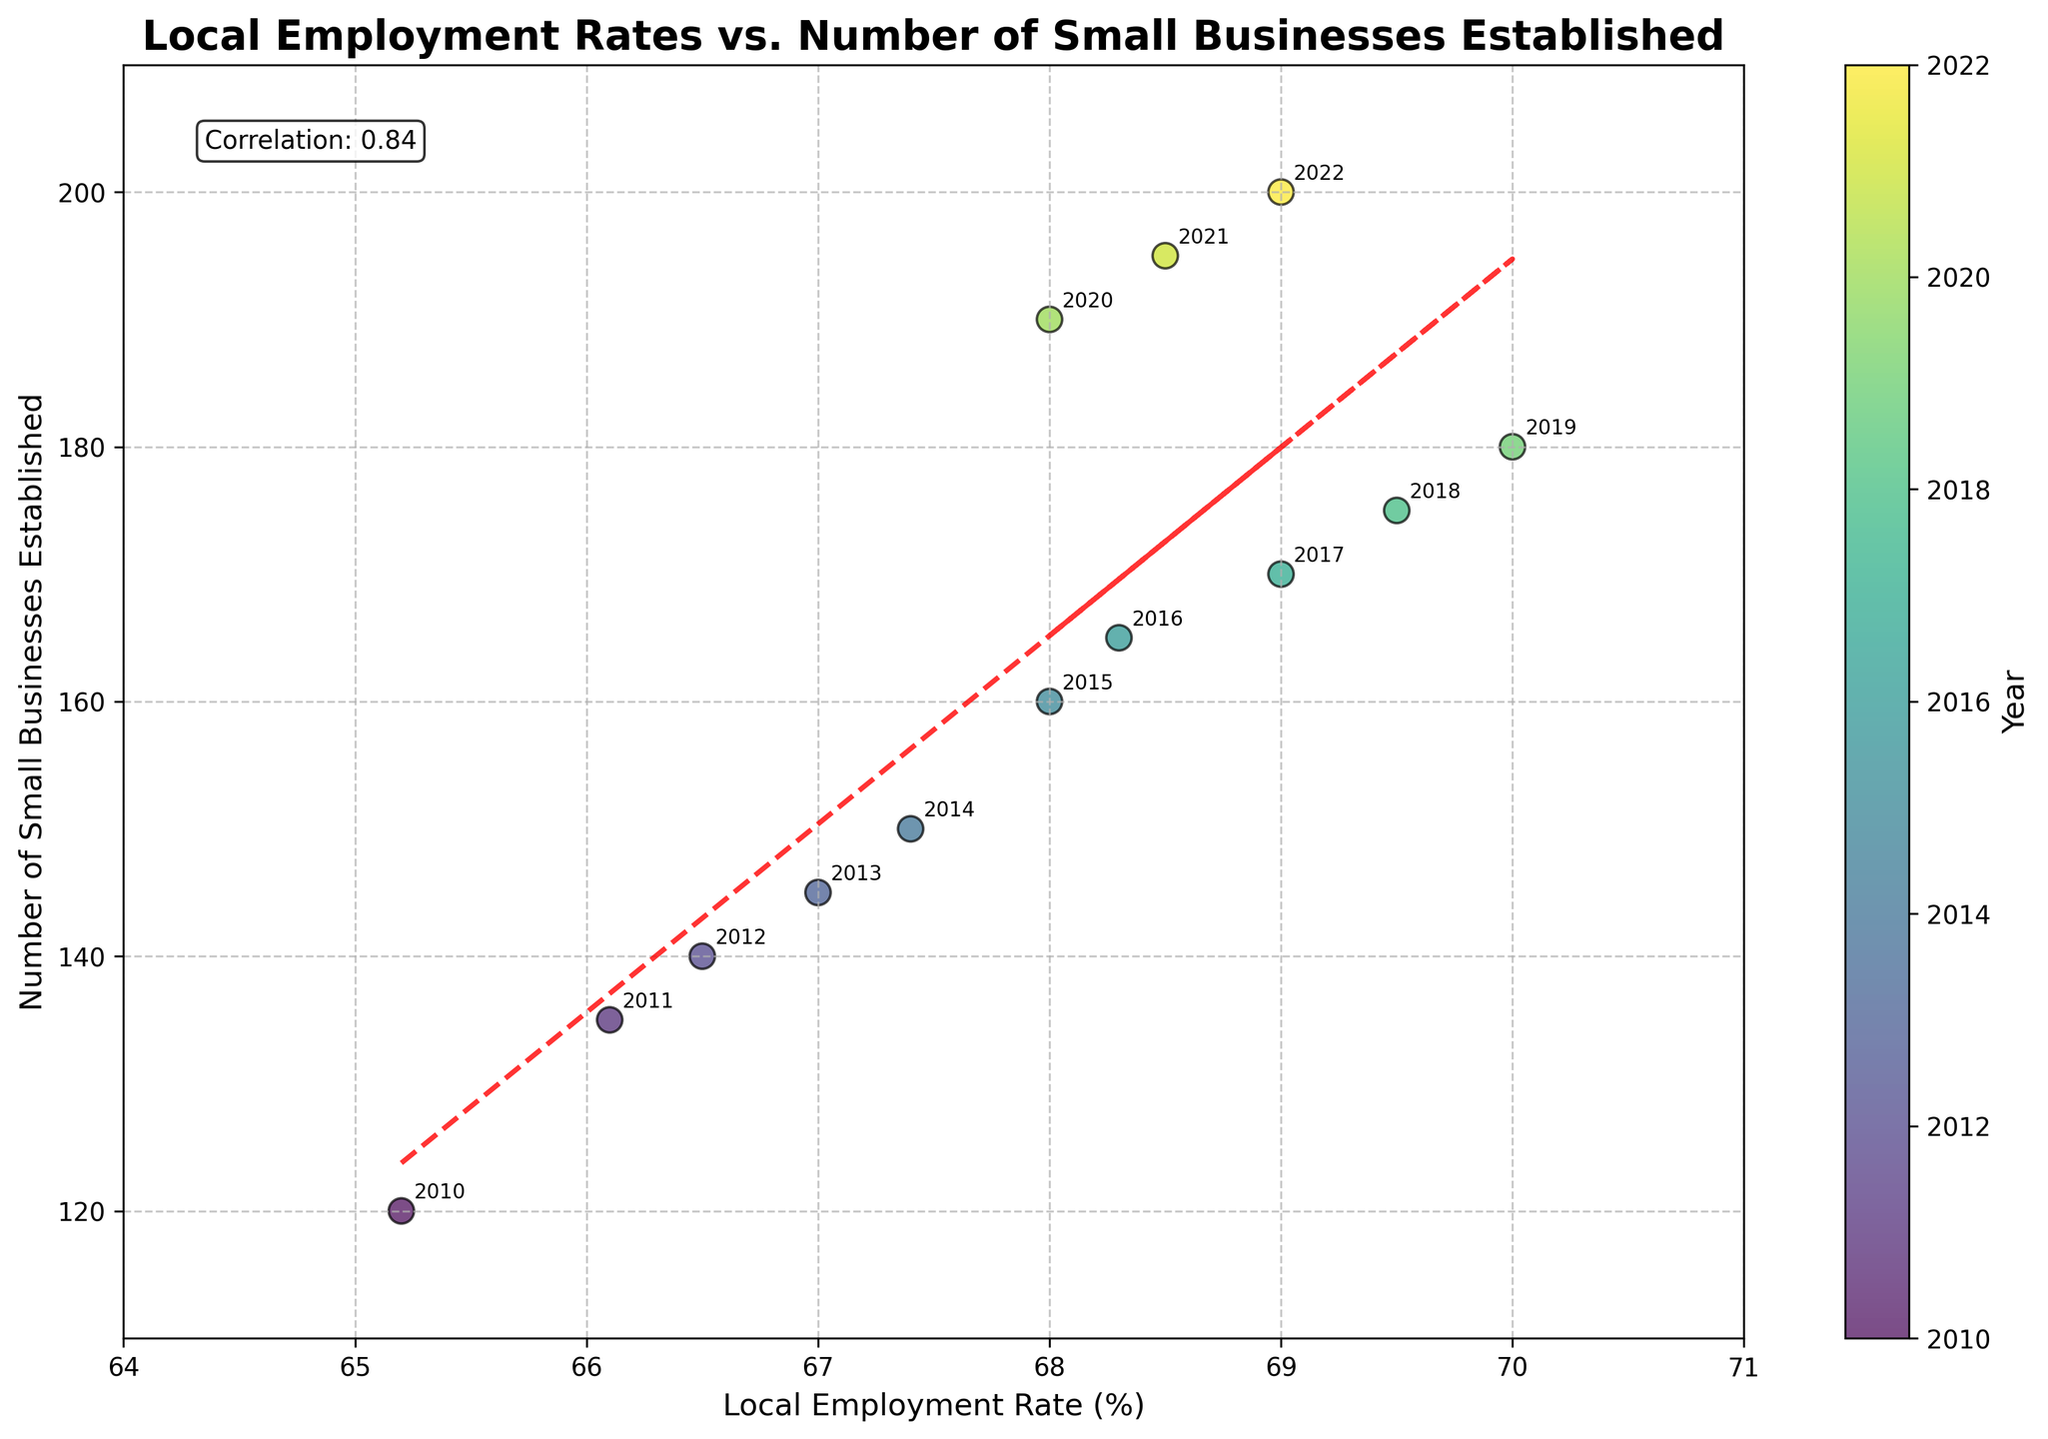What is the title of the plot? The title is typically displayed at the top of the plot. In this case, it is clearly marked as "Local Employment Rates vs. Number of Small Businesses Established".
Answer: Local Employment Rates vs. Number of Small Businesses Established What does the x-axis represent? The x-axis usually represents one of the variables in the plot, and here it is labeled as "Local Employment Rate (%)".
Answer: Local Employment Rate (%) Which year has the highest number of small businesses established, and what is the corresponding employment rate? By looking at the scatter points and their annotations, the highest number of small businesses established is in 2022 with 200 businesses, and the corresponding employment rate is 69%.
Answer: 2022, 69% What is the trend shown by the trend line? The trend line in the plot helps to visualize the overall relationship. Here it is an upward sloping dashed red line, indicating a positive correlation between local employment rates and the number of small businesses established.
Answer: Positive correlation How many years are represented in the scatter plot? Each scatter point is annotated with a year. By counting each unique annotation, there are 13 years represented.
Answer: 13 Which year had the most significant decrease in local employment rate? Comparing the years by looking at the scatter points, 2020 had a significant decrease in the local employment rate, dropping from the previous year 2019's 70% to 68%.
Answer: 2020 What is the correlation coefficient between local employment rates and the number of small businesses established, and what does it suggest? The correlation coefficient is displayed in a text box in the plot, which shows 'Correlation: 0.84'. This suggests a strong positive relationship between the two variables.
Answer: 0.84 What can be inferred about the relationship between local employment rates and the number of small businesses established in 2016 and 2017? By looking at the points for 2016 and 2017, we see that 2017 has a higher employment rate (69.0%) compared to 2016 (68.3%), and the number of small businesses established increased from 165 to 170. This indicates a positive trend during those years.
Answer: Positive trend What year saw a return to the previous peak after a decline and subsequent recovery in local employment rates? Observing the annotations and points, 2021 shows a return to an employment rate similar to 2019 (both close to 69%) after a dip in 2020.
Answer: 2021 